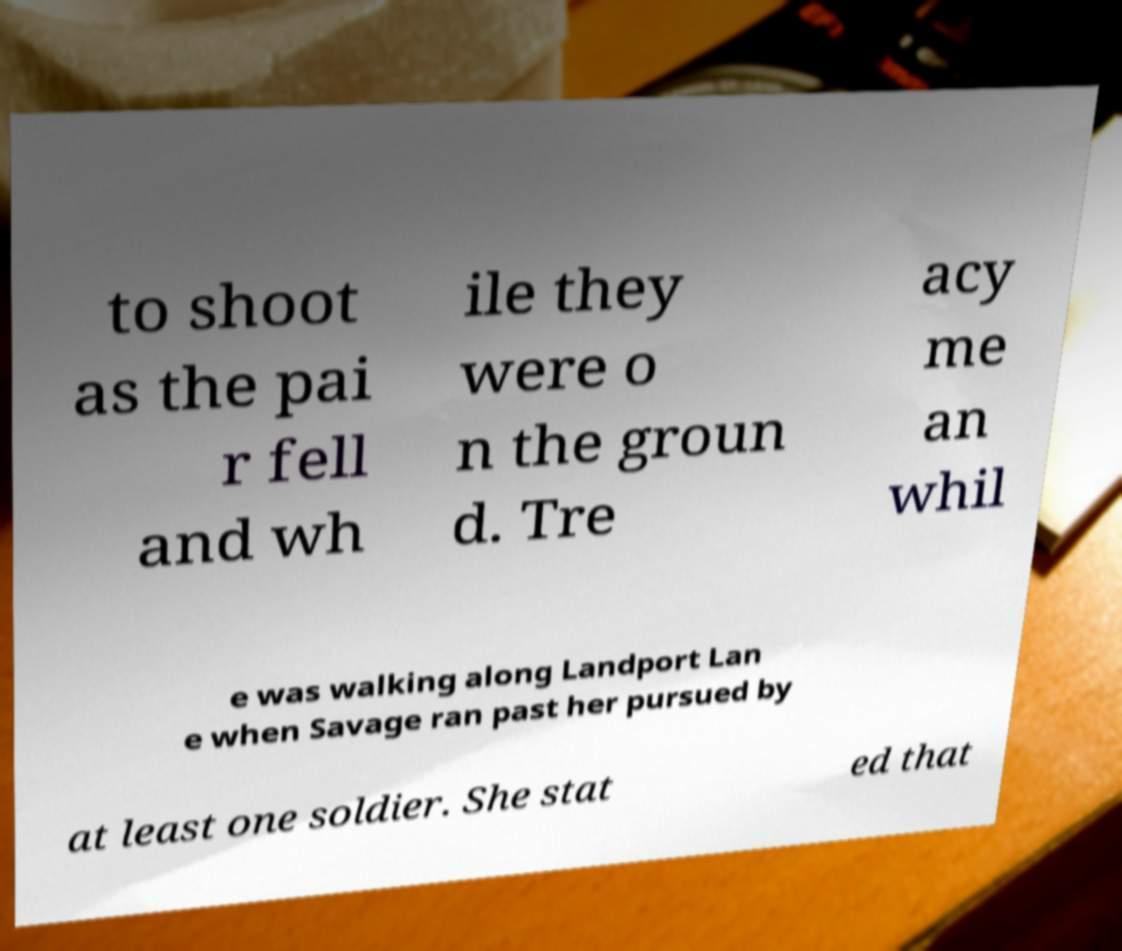Could you assist in decoding the text presented in this image and type it out clearly? to shoot as the pai r fell and wh ile they were o n the groun d. Tre acy me an whil e was walking along Landport Lan e when Savage ran past her pursued by at least one soldier. She stat ed that 